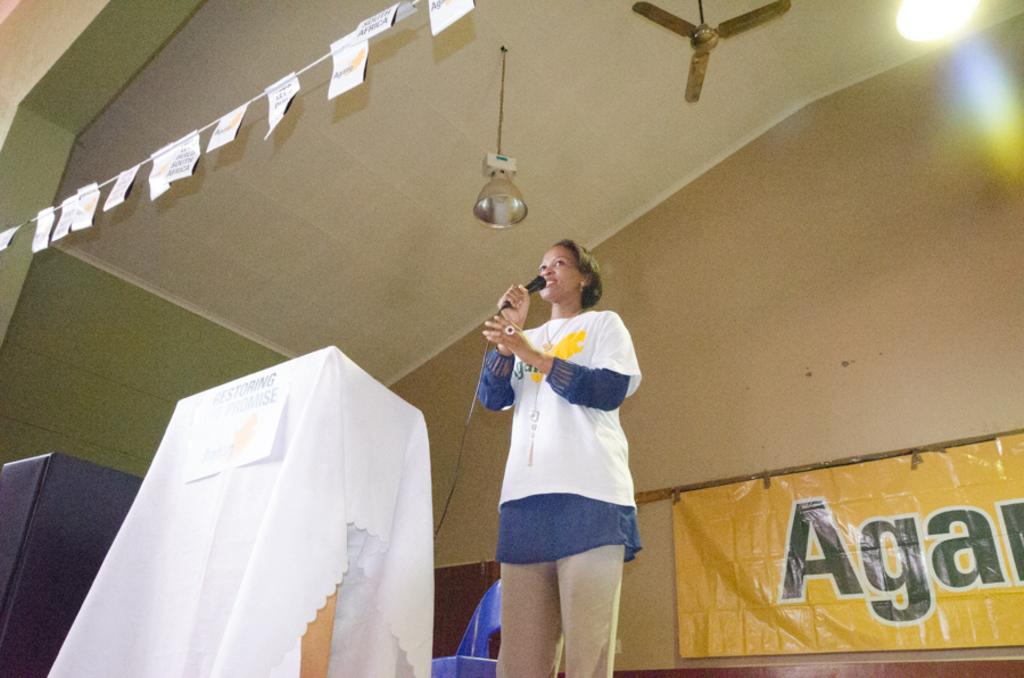Provide a one-sentence caption for the provided image. Lady is on the stage with a microphone speaking. 